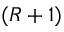<formula> <loc_0><loc_0><loc_500><loc_500>( R + 1 )</formula> 